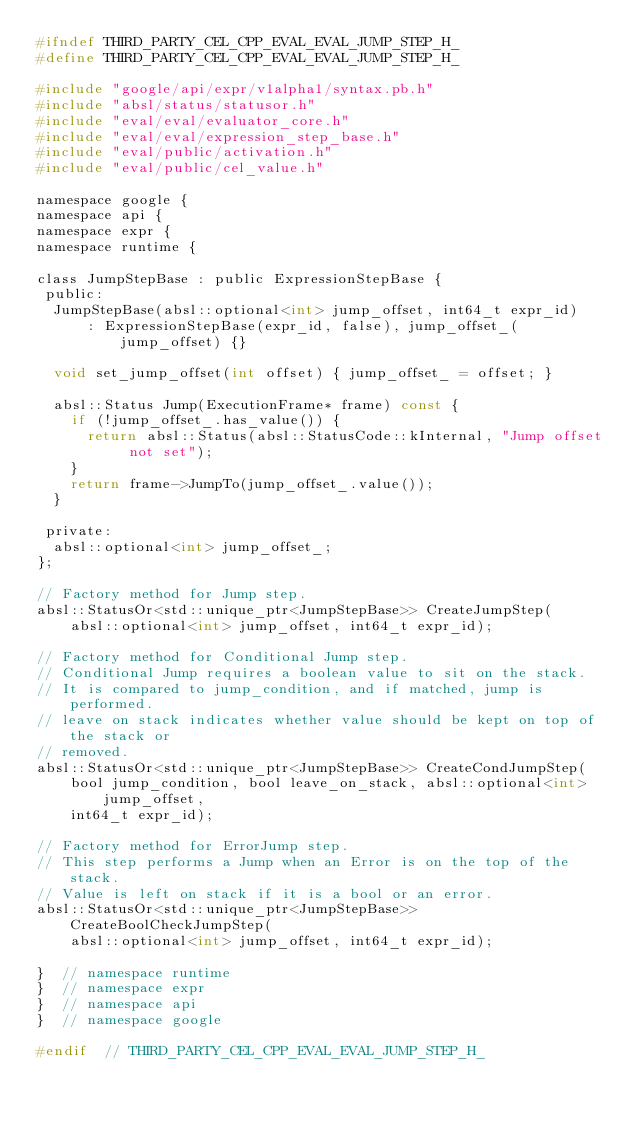Convert code to text. <code><loc_0><loc_0><loc_500><loc_500><_C_>#ifndef THIRD_PARTY_CEL_CPP_EVAL_EVAL_JUMP_STEP_H_
#define THIRD_PARTY_CEL_CPP_EVAL_EVAL_JUMP_STEP_H_

#include "google/api/expr/v1alpha1/syntax.pb.h"
#include "absl/status/statusor.h"
#include "eval/eval/evaluator_core.h"
#include "eval/eval/expression_step_base.h"
#include "eval/public/activation.h"
#include "eval/public/cel_value.h"

namespace google {
namespace api {
namespace expr {
namespace runtime {

class JumpStepBase : public ExpressionStepBase {
 public:
  JumpStepBase(absl::optional<int> jump_offset, int64_t expr_id)
      : ExpressionStepBase(expr_id, false), jump_offset_(jump_offset) {}

  void set_jump_offset(int offset) { jump_offset_ = offset; }

  absl::Status Jump(ExecutionFrame* frame) const {
    if (!jump_offset_.has_value()) {
      return absl::Status(absl::StatusCode::kInternal, "Jump offset not set");
    }
    return frame->JumpTo(jump_offset_.value());
  }

 private:
  absl::optional<int> jump_offset_;
};

// Factory method for Jump step.
absl::StatusOr<std::unique_ptr<JumpStepBase>> CreateJumpStep(
    absl::optional<int> jump_offset, int64_t expr_id);

// Factory method for Conditional Jump step.
// Conditional Jump requires a boolean value to sit on the stack.
// It is compared to jump_condition, and if matched, jump is performed.
// leave on stack indicates whether value should be kept on top of the stack or
// removed.
absl::StatusOr<std::unique_ptr<JumpStepBase>> CreateCondJumpStep(
    bool jump_condition, bool leave_on_stack, absl::optional<int> jump_offset,
    int64_t expr_id);

// Factory method for ErrorJump step.
// This step performs a Jump when an Error is on the top of the stack.
// Value is left on stack if it is a bool or an error.
absl::StatusOr<std::unique_ptr<JumpStepBase>> CreateBoolCheckJumpStep(
    absl::optional<int> jump_offset, int64_t expr_id);

}  // namespace runtime
}  // namespace expr
}  // namespace api
}  // namespace google

#endif  // THIRD_PARTY_CEL_CPP_EVAL_EVAL_JUMP_STEP_H_
</code> 